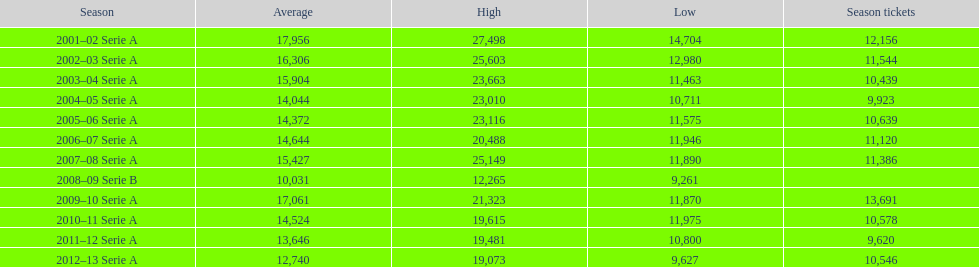What was the number of season tickets in 2007? 11,386. 